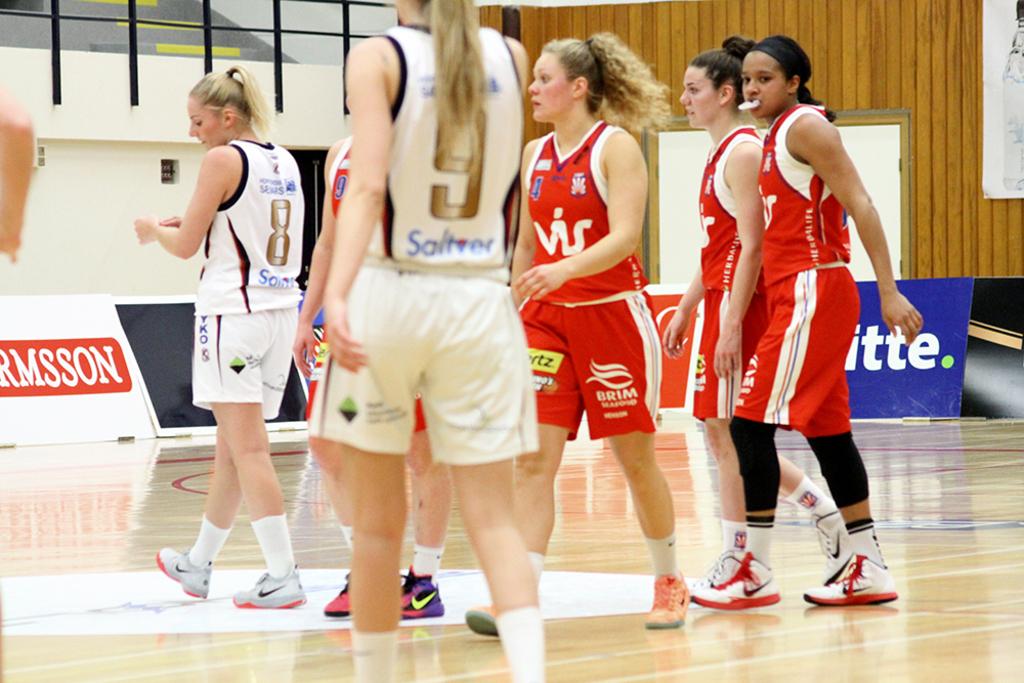What's the number written on the girl with a white shirt?
Give a very brief answer. 9. What number is on the girls shirt in white who is the furthest away?
Offer a very short reply. 8. 